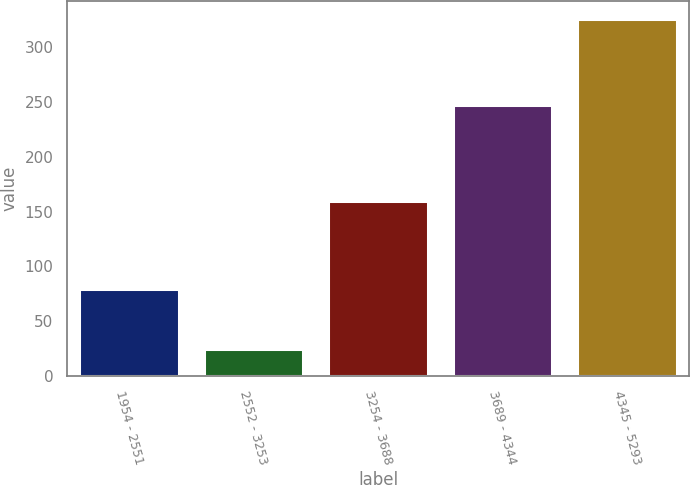<chart> <loc_0><loc_0><loc_500><loc_500><bar_chart><fcel>1954 - 2551<fcel>2552 - 3253<fcel>3254 - 3688<fcel>3689 - 4344<fcel>4345 - 5293<nl><fcel>79<fcel>25<fcel>160<fcel>247<fcel>326<nl></chart> 